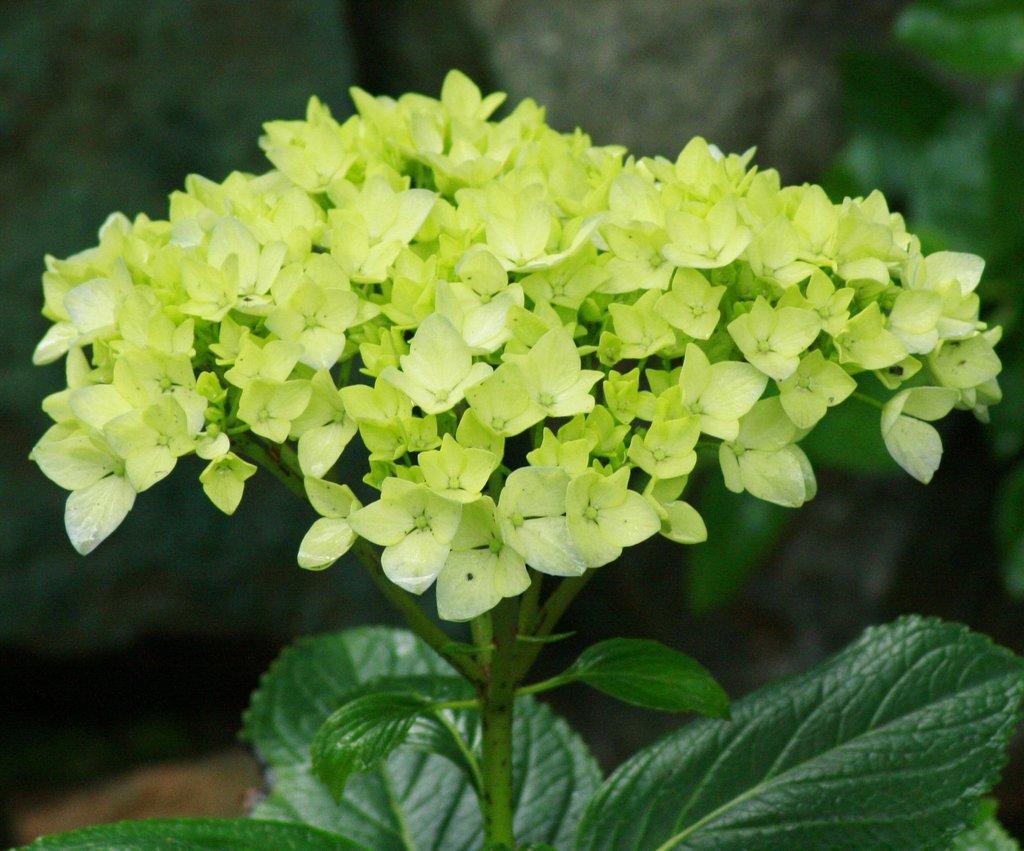Describe this image in one or two sentences. In this image in the front there is a plant and there are leaves and the background is blurry. 